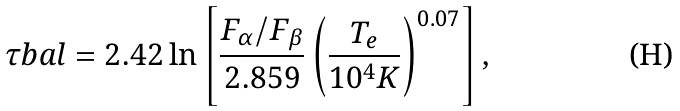Convert formula to latex. <formula><loc_0><loc_0><loc_500><loc_500>\tau b a l = 2 . 4 2 \ln \left [ \frac { F _ { \alpha } / F _ { \beta } } { 2 . 8 5 9 } \left ( \frac { T _ { e } } { 1 0 ^ { 4 } K } \right ) ^ { 0 . 0 7 } \right ] ,</formula> 